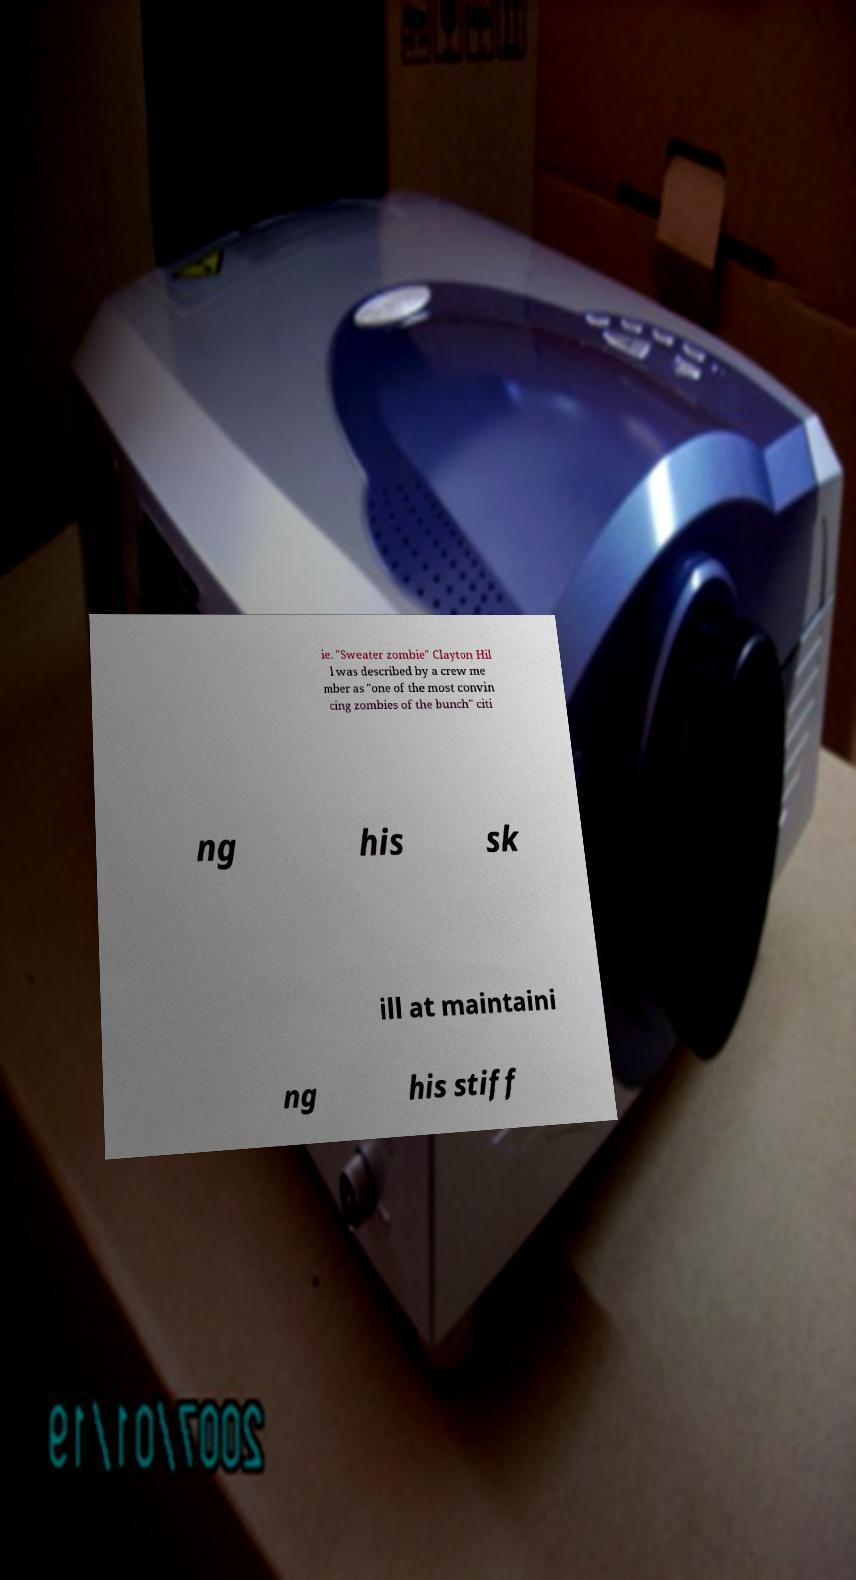What messages or text are displayed in this image? I need them in a readable, typed format. ie. "Sweater zombie" Clayton Hil l was described by a crew me mber as "one of the most convin cing zombies of the bunch" citi ng his sk ill at maintaini ng his stiff 